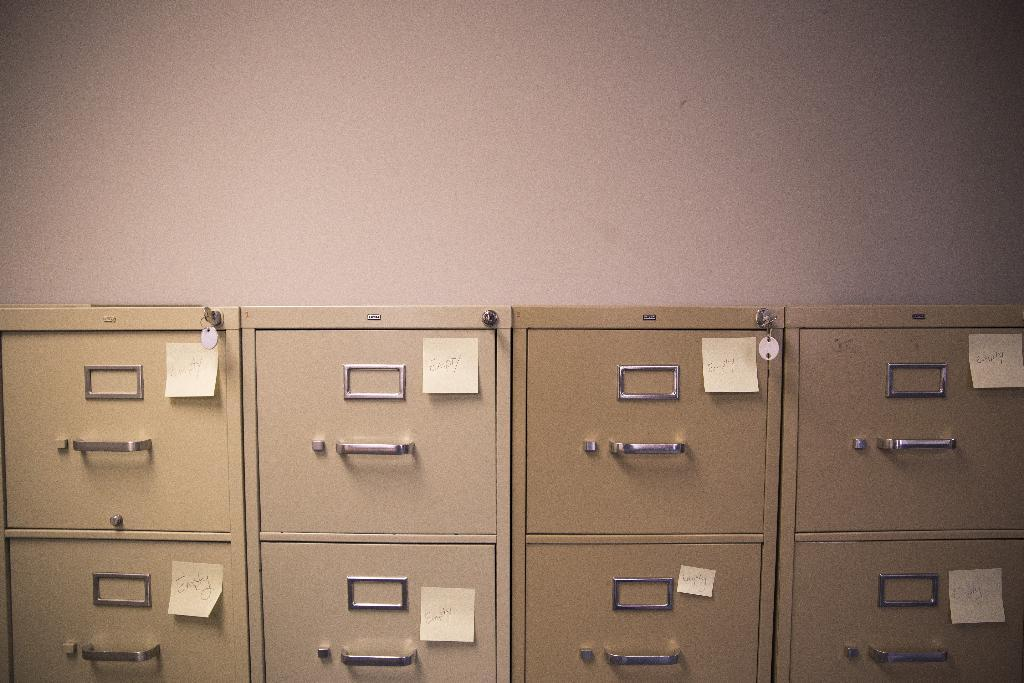What type of storage units are visible in the image? There are lockers in the image. What is attached to the lockers? Sticky notes are pasted on the lockers. What can be seen in the background of the image? There is a wall in the background of the image. What type of feeling can be seen on the cat's face in the image? There is no cat present in the image, so it is not possible to determine the feeling on its face. 